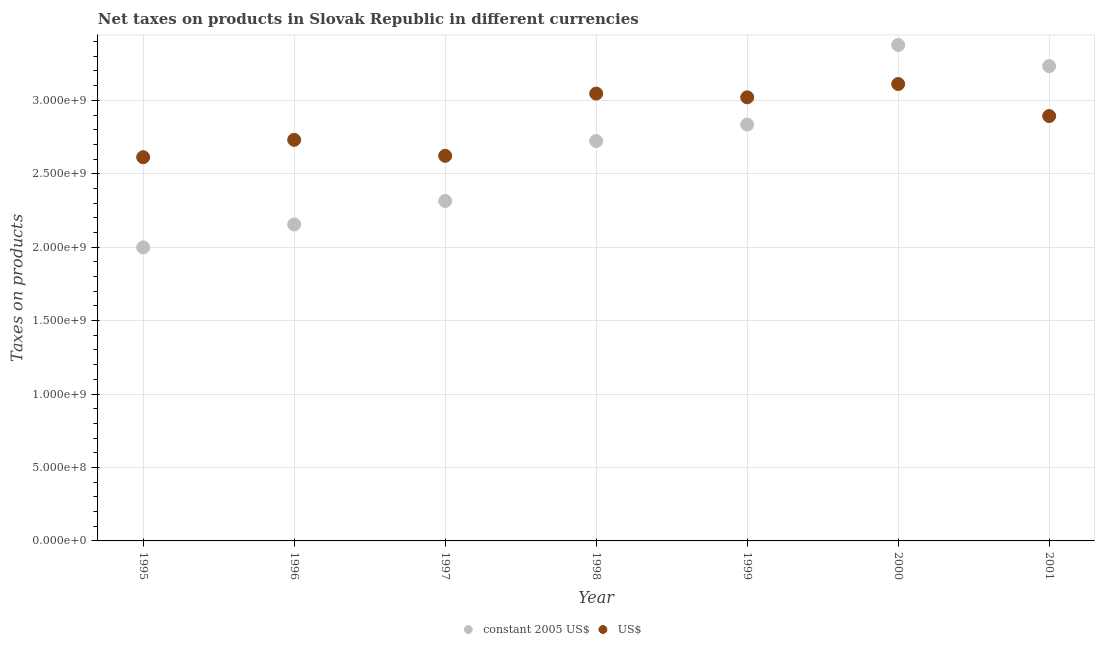How many different coloured dotlines are there?
Offer a very short reply. 2. Is the number of dotlines equal to the number of legend labels?
Offer a very short reply. Yes. What is the net taxes in us$ in 2001?
Make the answer very short. 2.89e+09. Across all years, what is the maximum net taxes in constant 2005 us$?
Keep it short and to the point. 3.38e+09. Across all years, what is the minimum net taxes in us$?
Offer a very short reply. 2.61e+09. In which year was the net taxes in us$ maximum?
Offer a very short reply. 2000. What is the total net taxes in us$ in the graph?
Your answer should be very brief. 2.00e+1. What is the difference between the net taxes in us$ in 1995 and that in 1999?
Your answer should be very brief. -4.08e+08. What is the difference between the net taxes in us$ in 1997 and the net taxes in constant 2005 us$ in 2000?
Ensure brevity in your answer.  -7.55e+08. What is the average net taxes in constant 2005 us$ per year?
Provide a succinct answer. 2.66e+09. In the year 2000, what is the difference between the net taxes in constant 2005 us$ and net taxes in us$?
Provide a short and direct response. 2.66e+08. What is the ratio of the net taxes in constant 2005 us$ in 1995 to that in 2001?
Offer a very short reply. 0.62. Is the net taxes in constant 2005 us$ in 1996 less than that in 2001?
Your answer should be very brief. Yes. What is the difference between the highest and the second highest net taxes in constant 2005 us$?
Provide a succinct answer. 1.44e+08. What is the difference between the highest and the lowest net taxes in us$?
Give a very brief answer. 4.98e+08. Is the net taxes in constant 2005 us$ strictly greater than the net taxes in us$ over the years?
Make the answer very short. No. Is the net taxes in constant 2005 us$ strictly less than the net taxes in us$ over the years?
Provide a short and direct response. No. How many dotlines are there?
Make the answer very short. 2. How many years are there in the graph?
Provide a short and direct response. 7. What is the title of the graph?
Your answer should be compact. Net taxes on products in Slovak Republic in different currencies. What is the label or title of the Y-axis?
Provide a short and direct response. Taxes on products. What is the Taxes on products in constant 2005 US$ in 1995?
Provide a succinct answer. 2.00e+09. What is the Taxes on products of US$ in 1995?
Give a very brief answer. 2.61e+09. What is the Taxes on products of constant 2005 US$ in 1996?
Provide a short and direct response. 2.15e+09. What is the Taxes on products of US$ in 1996?
Your answer should be very brief. 2.73e+09. What is the Taxes on products of constant 2005 US$ in 1997?
Your answer should be compact. 2.31e+09. What is the Taxes on products of US$ in 1997?
Your response must be concise. 2.62e+09. What is the Taxes on products in constant 2005 US$ in 1998?
Offer a terse response. 2.72e+09. What is the Taxes on products in US$ in 1998?
Give a very brief answer. 3.05e+09. What is the Taxes on products in constant 2005 US$ in 1999?
Your response must be concise. 2.83e+09. What is the Taxes on products in US$ in 1999?
Provide a short and direct response. 3.02e+09. What is the Taxes on products in constant 2005 US$ in 2000?
Provide a succinct answer. 3.38e+09. What is the Taxes on products of US$ in 2000?
Ensure brevity in your answer.  3.11e+09. What is the Taxes on products of constant 2005 US$ in 2001?
Give a very brief answer. 3.23e+09. What is the Taxes on products of US$ in 2001?
Ensure brevity in your answer.  2.89e+09. Across all years, what is the maximum Taxes on products of constant 2005 US$?
Offer a terse response. 3.38e+09. Across all years, what is the maximum Taxes on products of US$?
Your response must be concise. 3.11e+09. Across all years, what is the minimum Taxes on products of constant 2005 US$?
Provide a short and direct response. 2.00e+09. Across all years, what is the minimum Taxes on products in US$?
Keep it short and to the point. 2.61e+09. What is the total Taxes on products of constant 2005 US$ in the graph?
Make the answer very short. 1.86e+1. What is the total Taxes on products of US$ in the graph?
Your answer should be compact. 2.00e+1. What is the difference between the Taxes on products of constant 2005 US$ in 1995 and that in 1996?
Your response must be concise. -1.56e+08. What is the difference between the Taxes on products in US$ in 1995 and that in 1996?
Provide a short and direct response. -1.18e+08. What is the difference between the Taxes on products of constant 2005 US$ in 1995 and that in 1997?
Make the answer very short. -3.16e+08. What is the difference between the Taxes on products of US$ in 1995 and that in 1997?
Keep it short and to the point. -9.45e+06. What is the difference between the Taxes on products of constant 2005 US$ in 1995 and that in 1998?
Provide a succinct answer. -7.24e+08. What is the difference between the Taxes on products in US$ in 1995 and that in 1998?
Provide a succinct answer. -4.33e+08. What is the difference between the Taxes on products in constant 2005 US$ in 1995 and that in 1999?
Provide a succinct answer. -8.36e+08. What is the difference between the Taxes on products in US$ in 1995 and that in 1999?
Make the answer very short. -4.08e+08. What is the difference between the Taxes on products in constant 2005 US$ in 1995 and that in 2000?
Ensure brevity in your answer.  -1.38e+09. What is the difference between the Taxes on products in US$ in 1995 and that in 2000?
Ensure brevity in your answer.  -4.98e+08. What is the difference between the Taxes on products in constant 2005 US$ in 1995 and that in 2001?
Your answer should be very brief. -1.23e+09. What is the difference between the Taxes on products in US$ in 1995 and that in 2001?
Offer a terse response. -2.80e+08. What is the difference between the Taxes on products in constant 2005 US$ in 1996 and that in 1997?
Your answer should be compact. -1.60e+08. What is the difference between the Taxes on products of US$ in 1996 and that in 1997?
Provide a short and direct response. 1.09e+08. What is the difference between the Taxes on products of constant 2005 US$ in 1996 and that in 1998?
Keep it short and to the point. -5.68e+08. What is the difference between the Taxes on products of US$ in 1996 and that in 1998?
Your response must be concise. -3.15e+08. What is the difference between the Taxes on products of constant 2005 US$ in 1996 and that in 1999?
Offer a very short reply. -6.80e+08. What is the difference between the Taxes on products in US$ in 1996 and that in 1999?
Ensure brevity in your answer.  -2.89e+08. What is the difference between the Taxes on products in constant 2005 US$ in 1996 and that in 2000?
Give a very brief answer. -1.22e+09. What is the difference between the Taxes on products in US$ in 1996 and that in 2000?
Ensure brevity in your answer.  -3.80e+08. What is the difference between the Taxes on products of constant 2005 US$ in 1996 and that in 2001?
Provide a succinct answer. -1.08e+09. What is the difference between the Taxes on products of US$ in 1996 and that in 2001?
Make the answer very short. -1.62e+08. What is the difference between the Taxes on products of constant 2005 US$ in 1997 and that in 1998?
Your response must be concise. -4.08e+08. What is the difference between the Taxes on products in US$ in 1997 and that in 1998?
Give a very brief answer. -4.24e+08. What is the difference between the Taxes on products of constant 2005 US$ in 1997 and that in 1999?
Keep it short and to the point. -5.20e+08. What is the difference between the Taxes on products of US$ in 1997 and that in 1999?
Ensure brevity in your answer.  -3.98e+08. What is the difference between the Taxes on products of constant 2005 US$ in 1997 and that in 2000?
Make the answer very short. -1.06e+09. What is the difference between the Taxes on products in US$ in 1997 and that in 2000?
Keep it short and to the point. -4.89e+08. What is the difference between the Taxes on products of constant 2005 US$ in 1997 and that in 2001?
Provide a short and direct response. -9.18e+08. What is the difference between the Taxes on products in US$ in 1997 and that in 2001?
Your response must be concise. -2.71e+08. What is the difference between the Taxes on products of constant 2005 US$ in 1998 and that in 1999?
Make the answer very short. -1.12e+08. What is the difference between the Taxes on products in US$ in 1998 and that in 1999?
Give a very brief answer. 2.57e+07. What is the difference between the Taxes on products in constant 2005 US$ in 1998 and that in 2000?
Provide a succinct answer. -6.54e+08. What is the difference between the Taxes on products of US$ in 1998 and that in 2000?
Your answer should be compact. -6.50e+07. What is the difference between the Taxes on products of constant 2005 US$ in 1998 and that in 2001?
Your response must be concise. -5.10e+08. What is the difference between the Taxes on products in US$ in 1998 and that in 2001?
Make the answer very short. 1.53e+08. What is the difference between the Taxes on products of constant 2005 US$ in 1999 and that in 2000?
Keep it short and to the point. -5.42e+08. What is the difference between the Taxes on products in US$ in 1999 and that in 2000?
Provide a succinct answer. -9.08e+07. What is the difference between the Taxes on products of constant 2005 US$ in 1999 and that in 2001?
Your answer should be very brief. -3.98e+08. What is the difference between the Taxes on products of US$ in 1999 and that in 2001?
Your answer should be very brief. 1.27e+08. What is the difference between the Taxes on products of constant 2005 US$ in 2000 and that in 2001?
Make the answer very short. 1.44e+08. What is the difference between the Taxes on products in US$ in 2000 and that in 2001?
Give a very brief answer. 2.18e+08. What is the difference between the Taxes on products in constant 2005 US$ in 1995 and the Taxes on products in US$ in 1996?
Keep it short and to the point. -7.32e+08. What is the difference between the Taxes on products in constant 2005 US$ in 1995 and the Taxes on products in US$ in 1997?
Keep it short and to the point. -6.23e+08. What is the difference between the Taxes on products of constant 2005 US$ in 1995 and the Taxes on products of US$ in 1998?
Your answer should be compact. -1.05e+09. What is the difference between the Taxes on products in constant 2005 US$ in 1995 and the Taxes on products in US$ in 1999?
Your answer should be very brief. -1.02e+09. What is the difference between the Taxes on products of constant 2005 US$ in 1995 and the Taxes on products of US$ in 2000?
Give a very brief answer. -1.11e+09. What is the difference between the Taxes on products in constant 2005 US$ in 1995 and the Taxes on products in US$ in 2001?
Give a very brief answer. -8.94e+08. What is the difference between the Taxes on products in constant 2005 US$ in 1996 and the Taxes on products in US$ in 1997?
Your response must be concise. -4.67e+08. What is the difference between the Taxes on products in constant 2005 US$ in 1996 and the Taxes on products in US$ in 1998?
Your answer should be very brief. -8.91e+08. What is the difference between the Taxes on products of constant 2005 US$ in 1996 and the Taxes on products of US$ in 1999?
Your response must be concise. -8.65e+08. What is the difference between the Taxes on products in constant 2005 US$ in 1996 and the Taxes on products in US$ in 2000?
Ensure brevity in your answer.  -9.56e+08. What is the difference between the Taxes on products of constant 2005 US$ in 1996 and the Taxes on products of US$ in 2001?
Make the answer very short. -7.38e+08. What is the difference between the Taxes on products in constant 2005 US$ in 1997 and the Taxes on products in US$ in 1998?
Ensure brevity in your answer.  -7.31e+08. What is the difference between the Taxes on products in constant 2005 US$ in 1997 and the Taxes on products in US$ in 1999?
Make the answer very short. -7.06e+08. What is the difference between the Taxes on products of constant 2005 US$ in 1997 and the Taxes on products of US$ in 2000?
Your answer should be compact. -7.96e+08. What is the difference between the Taxes on products in constant 2005 US$ in 1997 and the Taxes on products in US$ in 2001?
Your response must be concise. -5.78e+08. What is the difference between the Taxes on products of constant 2005 US$ in 1998 and the Taxes on products of US$ in 1999?
Your answer should be very brief. -2.97e+08. What is the difference between the Taxes on products in constant 2005 US$ in 1998 and the Taxes on products in US$ in 2000?
Your response must be concise. -3.88e+08. What is the difference between the Taxes on products of constant 2005 US$ in 1998 and the Taxes on products of US$ in 2001?
Make the answer very short. -1.70e+08. What is the difference between the Taxes on products in constant 2005 US$ in 1999 and the Taxes on products in US$ in 2000?
Make the answer very short. -2.76e+08. What is the difference between the Taxes on products of constant 2005 US$ in 1999 and the Taxes on products of US$ in 2001?
Give a very brief answer. -5.80e+07. What is the difference between the Taxes on products of constant 2005 US$ in 2000 and the Taxes on products of US$ in 2001?
Give a very brief answer. 4.84e+08. What is the average Taxes on products in constant 2005 US$ per year?
Your answer should be compact. 2.66e+09. What is the average Taxes on products of US$ per year?
Offer a very short reply. 2.86e+09. In the year 1995, what is the difference between the Taxes on products in constant 2005 US$ and Taxes on products in US$?
Give a very brief answer. -6.14e+08. In the year 1996, what is the difference between the Taxes on products in constant 2005 US$ and Taxes on products in US$?
Provide a succinct answer. -5.76e+08. In the year 1997, what is the difference between the Taxes on products in constant 2005 US$ and Taxes on products in US$?
Offer a terse response. -3.08e+08. In the year 1998, what is the difference between the Taxes on products in constant 2005 US$ and Taxes on products in US$?
Provide a short and direct response. -3.23e+08. In the year 1999, what is the difference between the Taxes on products of constant 2005 US$ and Taxes on products of US$?
Provide a succinct answer. -1.85e+08. In the year 2000, what is the difference between the Taxes on products of constant 2005 US$ and Taxes on products of US$?
Ensure brevity in your answer.  2.66e+08. In the year 2001, what is the difference between the Taxes on products of constant 2005 US$ and Taxes on products of US$?
Make the answer very short. 3.40e+08. What is the ratio of the Taxes on products in constant 2005 US$ in 1995 to that in 1996?
Provide a short and direct response. 0.93. What is the ratio of the Taxes on products of US$ in 1995 to that in 1996?
Make the answer very short. 0.96. What is the ratio of the Taxes on products of constant 2005 US$ in 1995 to that in 1997?
Provide a short and direct response. 0.86. What is the ratio of the Taxes on products in US$ in 1995 to that in 1997?
Offer a very short reply. 1. What is the ratio of the Taxes on products in constant 2005 US$ in 1995 to that in 1998?
Provide a succinct answer. 0.73. What is the ratio of the Taxes on products in US$ in 1995 to that in 1998?
Make the answer very short. 0.86. What is the ratio of the Taxes on products of constant 2005 US$ in 1995 to that in 1999?
Give a very brief answer. 0.71. What is the ratio of the Taxes on products in US$ in 1995 to that in 1999?
Your response must be concise. 0.87. What is the ratio of the Taxes on products in constant 2005 US$ in 1995 to that in 2000?
Make the answer very short. 0.59. What is the ratio of the Taxes on products in US$ in 1995 to that in 2000?
Offer a terse response. 0.84. What is the ratio of the Taxes on products in constant 2005 US$ in 1995 to that in 2001?
Ensure brevity in your answer.  0.62. What is the ratio of the Taxes on products of US$ in 1995 to that in 2001?
Your answer should be very brief. 0.9. What is the ratio of the Taxes on products of constant 2005 US$ in 1996 to that in 1997?
Provide a short and direct response. 0.93. What is the ratio of the Taxes on products in US$ in 1996 to that in 1997?
Give a very brief answer. 1.04. What is the ratio of the Taxes on products in constant 2005 US$ in 1996 to that in 1998?
Give a very brief answer. 0.79. What is the ratio of the Taxes on products in US$ in 1996 to that in 1998?
Keep it short and to the point. 0.9. What is the ratio of the Taxes on products in constant 2005 US$ in 1996 to that in 1999?
Offer a terse response. 0.76. What is the ratio of the Taxes on products of US$ in 1996 to that in 1999?
Keep it short and to the point. 0.9. What is the ratio of the Taxes on products in constant 2005 US$ in 1996 to that in 2000?
Make the answer very short. 0.64. What is the ratio of the Taxes on products of US$ in 1996 to that in 2000?
Make the answer very short. 0.88. What is the ratio of the Taxes on products of constant 2005 US$ in 1996 to that in 2001?
Offer a terse response. 0.67. What is the ratio of the Taxes on products in US$ in 1996 to that in 2001?
Keep it short and to the point. 0.94. What is the ratio of the Taxes on products in constant 2005 US$ in 1997 to that in 1998?
Your response must be concise. 0.85. What is the ratio of the Taxes on products of US$ in 1997 to that in 1998?
Provide a short and direct response. 0.86. What is the ratio of the Taxes on products of constant 2005 US$ in 1997 to that in 1999?
Provide a short and direct response. 0.82. What is the ratio of the Taxes on products of US$ in 1997 to that in 1999?
Give a very brief answer. 0.87. What is the ratio of the Taxes on products in constant 2005 US$ in 1997 to that in 2000?
Your answer should be very brief. 0.69. What is the ratio of the Taxes on products in US$ in 1997 to that in 2000?
Your answer should be very brief. 0.84. What is the ratio of the Taxes on products of constant 2005 US$ in 1997 to that in 2001?
Keep it short and to the point. 0.72. What is the ratio of the Taxes on products in US$ in 1997 to that in 2001?
Make the answer very short. 0.91. What is the ratio of the Taxes on products of constant 2005 US$ in 1998 to that in 1999?
Your answer should be very brief. 0.96. What is the ratio of the Taxes on products in US$ in 1998 to that in 1999?
Ensure brevity in your answer.  1.01. What is the ratio of the Taxes on products in constant 2005 US$ in 1998 to that in 2000?
Offer a very short reply. 0.81. What is the ratio of the Taxes on products in US$ in 1998 to that in 2000?
Keep it short and to the point. 0.98. What is the ratio of the Taxes on products of constant 2005 US$ in 1998 to that in 2001?
Offer a terse response. 0.84. What is the ratio of the Taxes on products of US$ in 1998 to that in 2001?
Make the answer very short. 1.05. What is the ratio of the Taxes on products in constant 2005 US$ in 1999 to that in 2000?
Offer a terse response. 0.84. What is the ratio of the Taxes on products of US$ in 1999 to that in 2000?
Ensure brevity in your answer.  0.97. What is the ratio of the Taxes on products in constant 2005 US$ in 1999 to that in 2001?
Offer a terse response. 0.88. What is the ratio of the Taxes on products in US$ in 1999 to that in 2001?
Ensure brevity in your answer.  1.04. What is the ratio of the Taxes on products in constant 2005 US$ in 2000 to that in 2001?
Your answer should be compact. 1.04. What is the ratio of the Taxes on products of US$ in 2000 to that in 2001?
Your answer should be very brief. 1.08. What is the difference between the highest and the second highest Taxes on products of constant 2005 US$?
Your response must be concise. 1.44e+08. What is the difference between the highest and the second highest Taxes on products in US$?
Offer a very short reply. 6.50e+07. What is the difference between the highest and the lowest Taxes on products in constant 2005 US$?
Offer a terse response. 1.38e+09. What is the difference between the highest and the lowest Taxes on products of US$?
Provide a short and direct response. 4.98e+08. 